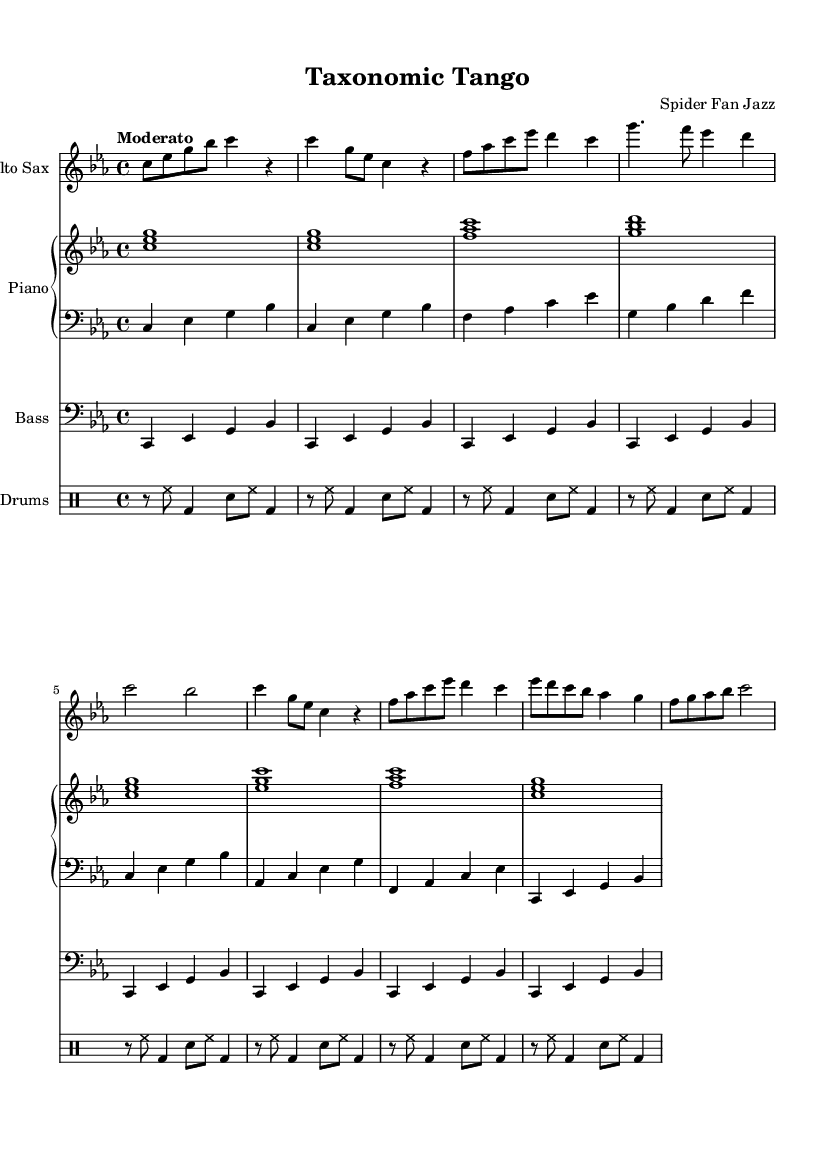What is the key signature of this music? The key signature is C minor, which has three flats: B-flat, E-flat, and A-flat. You can determine this by looking for the flats indicated at the beginning of the staff.
Answer: C minor What is the time signature of this piece? The time signature is 4/4, which means there are four beats in each measure and a quarter note gets one beat. This is indicated at the beginning of the sheet music next to the key signature.
Answer: 4/4 What is the tempo marking for this piece? The tempo marking is "Moderato," which indicates a moderate speed for the performance. This marking is typically found above the staff at the beginning of the piece.
Answer: Moderato How many measures are in section A? Section A contains 4 measures as counted from both parts of the repeated section (the first A and the second A) in the score. Each vocal line and the melody contribute to the measure count.
Answer: 4 What instruments are featured in this score? The instruments featured in this score are alto saxophone, piano (with both right and left hand parts), bass, and drums. You can identify the instruments listed at the beginning of each staff in the score.
Answer: Alto Sax, Piano, Bass, Drums How many times is the bass pattern repeated? The bass pattern is repeated 8 times as indicated by the repeat notation. You can see the instruction 'repeat unfold 8' in the bass music section, confirming the repetition.
Answer: 8 